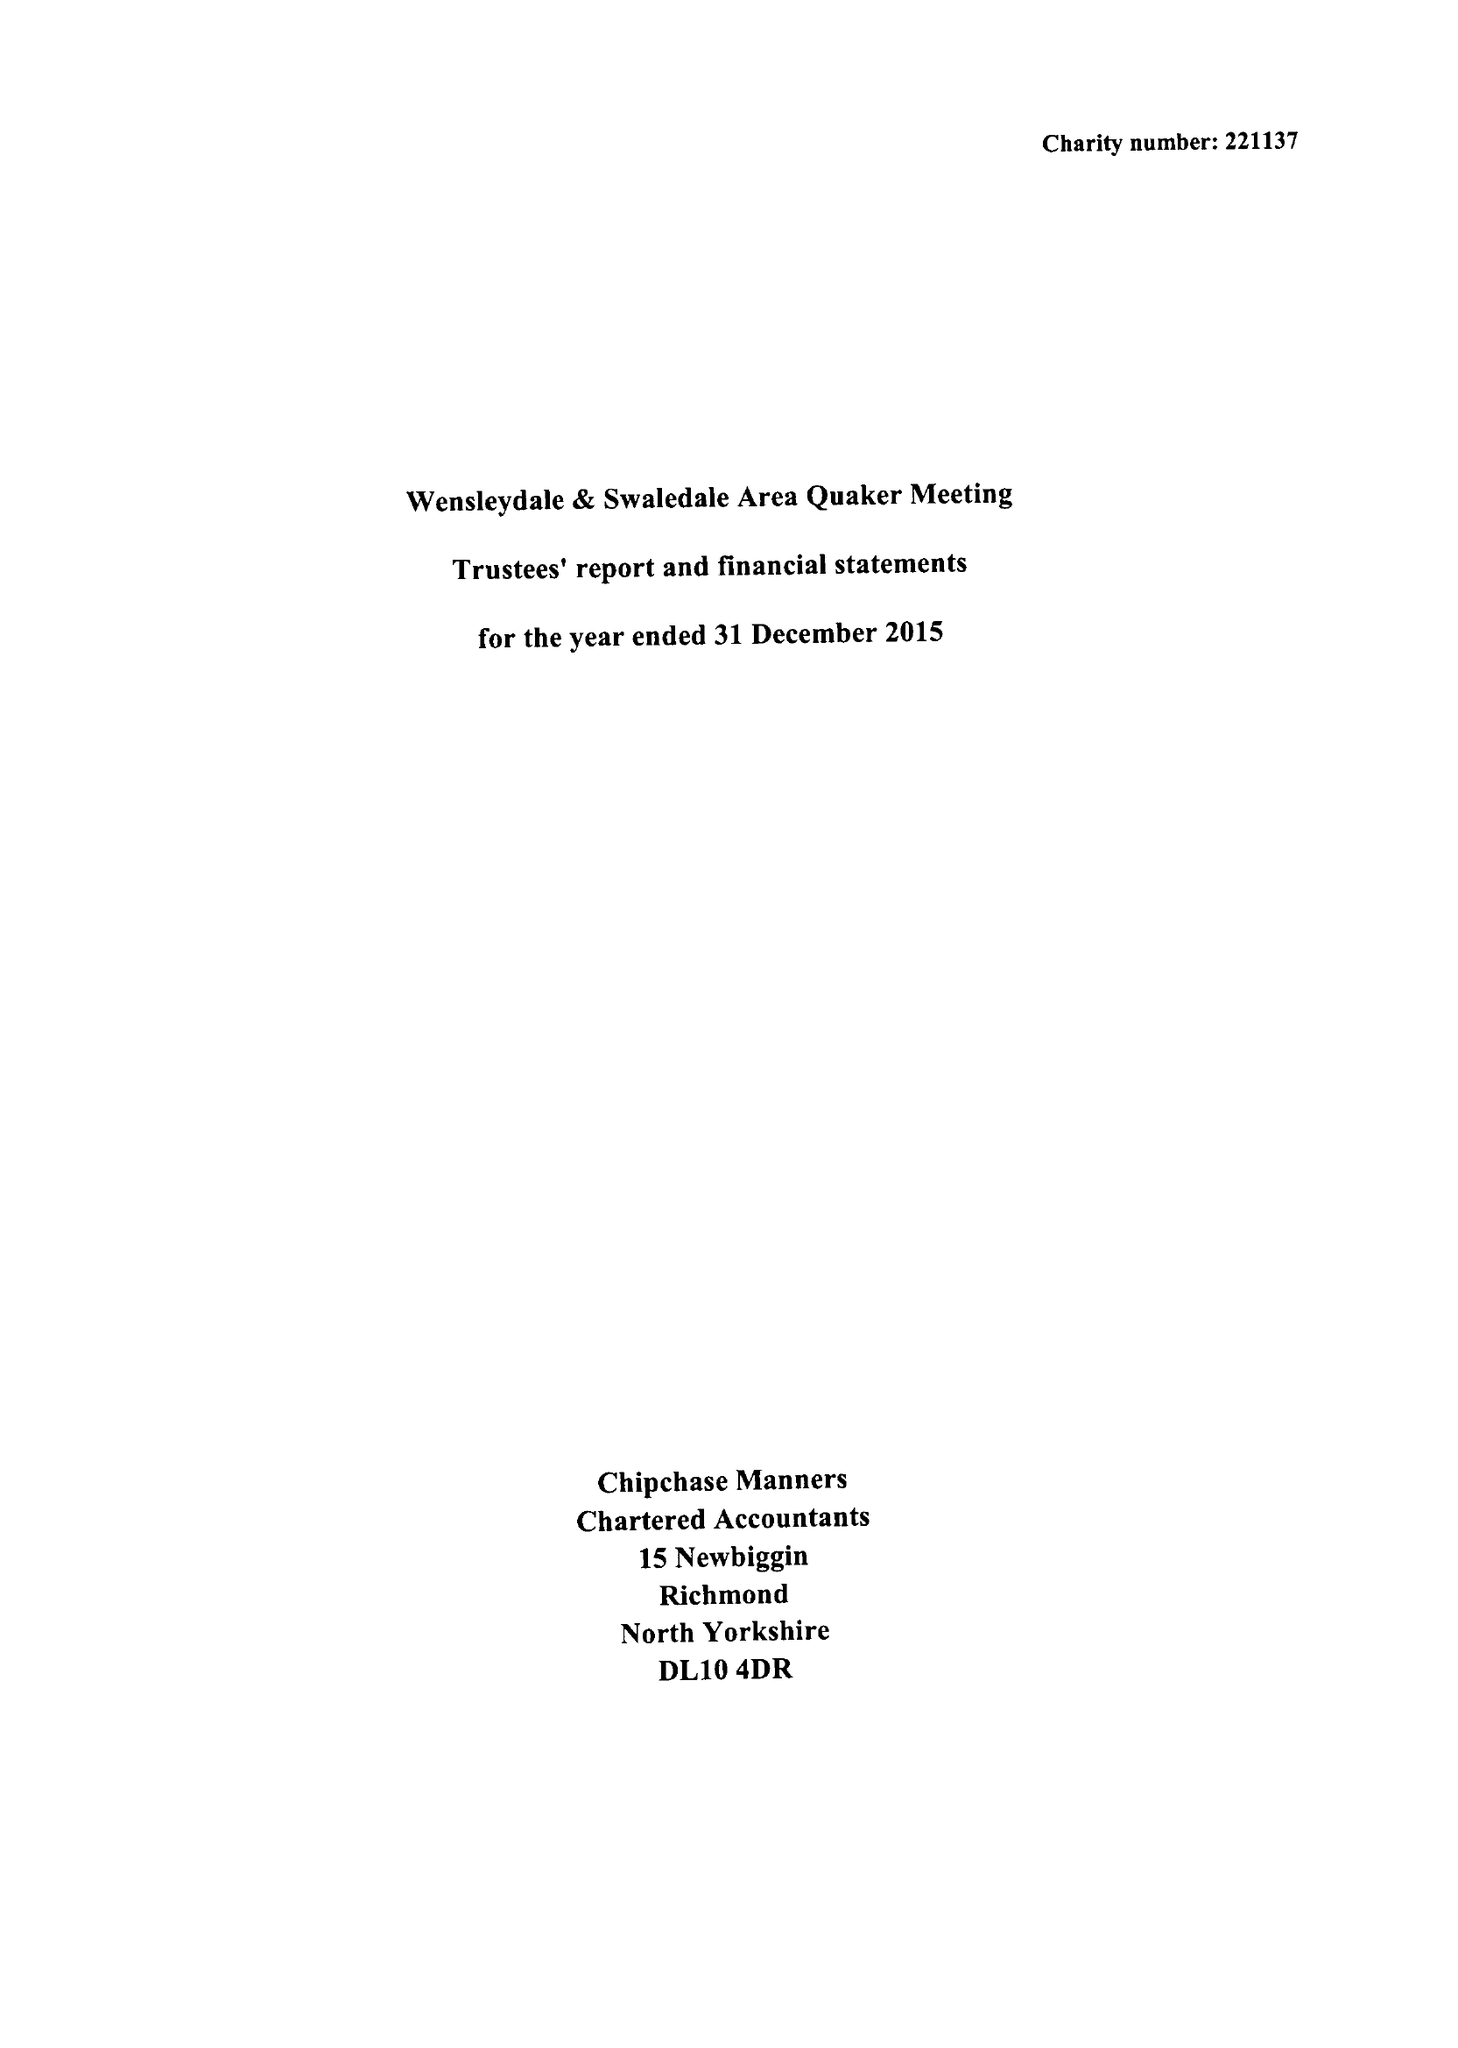What is the value for the income_annually_in_british_pounds?
Answer the question using a single word or phrase. 56273.00 